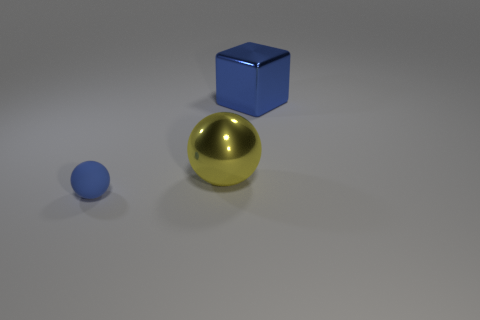How large do you think the blue cube is compared to the small blue sphere? Judging by the image, the blue cube appears to be significantly larger than the small blue sphere. Its dimensions suggest that the cube could be roughly three to four times the diameter of the smaller sphere in size. 